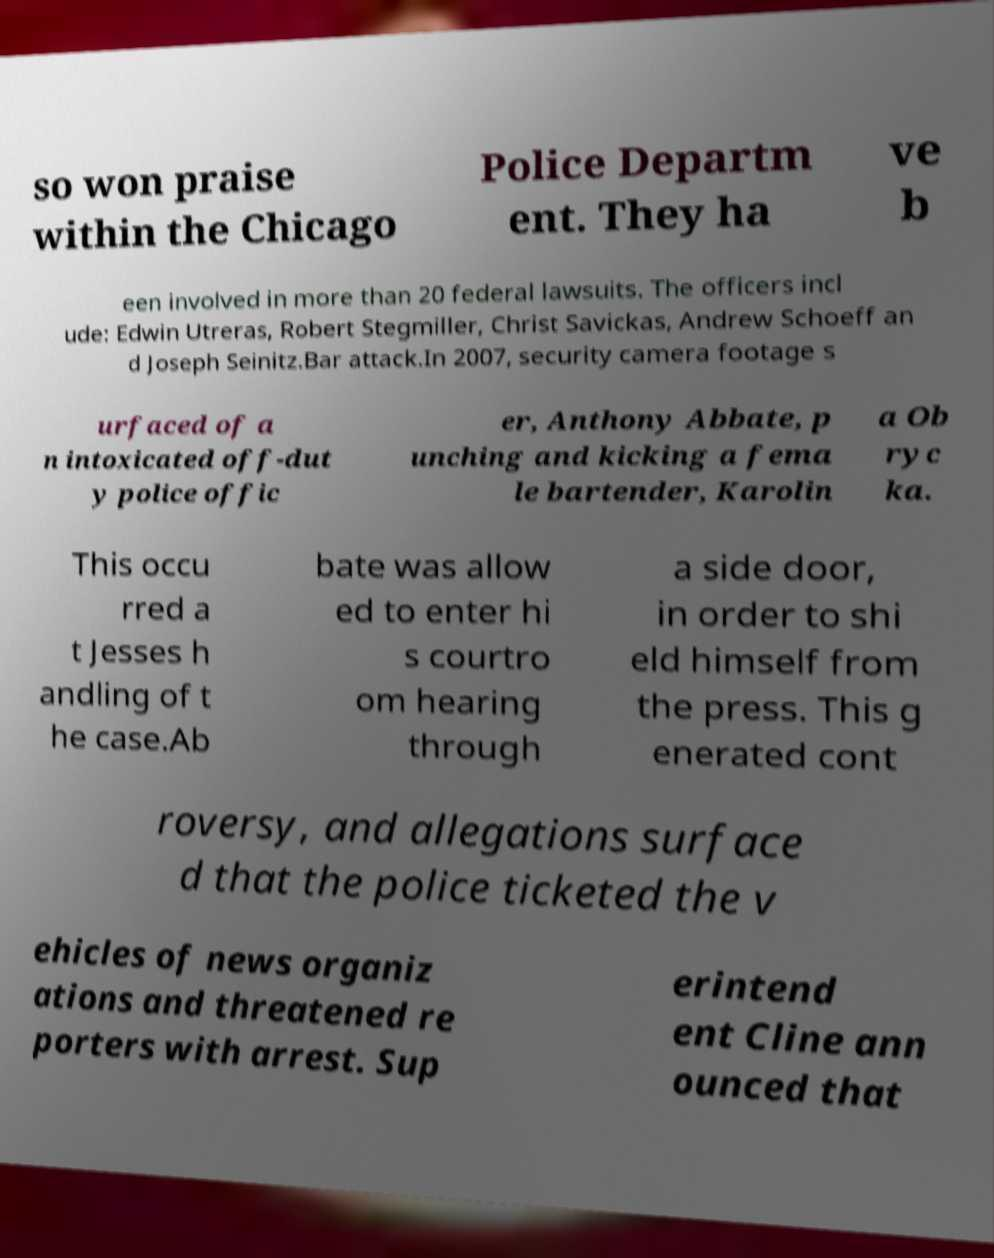What messages or text are displayed in this image? I need them in a readable, typed format. so won praise within the Chicago Police Departm ent. They ha ve b een involved in more than 20 federal lawsuits. The officers incl ude: Edwin Utreras, Robert Stegmiller, Christ Savickas, Andrew Schoeff an d Joseph Seinitz.Bar attack.In 2007, security camera footage s urfaced of a n intoxicated off-dut y police offic er, Anthony Abbate, p unching and kicking a fema le bartender, Karolin a Ob ryc ka. This occu rred a t Jesses h andling of t he case.Ab bate was allow ed to enter hi s courtro om hearing through a side door, in order to shi eld himself from the press. This g enerated cont roversy, and allegations surface d that the police ticketed the v ehicles of news organiz ations and threatened re porters with arrest. Sup erintend ent Cline ann ounced that 